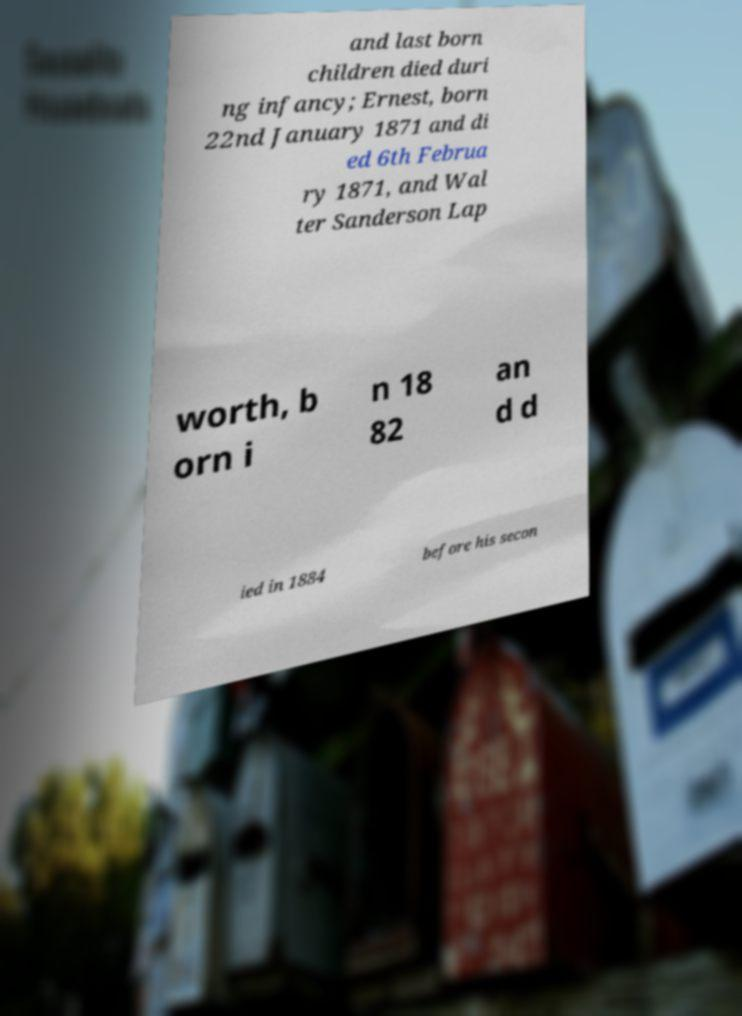I need the written content from this picture converted into text. Can you do that? and last born children died duri ng infancy; Ernest, born 22nd January 1871 and di ed 6th Februa ry 1871, and Wal ter Sanderson Lap worth, b orn i n 18 82 an d d ied in 1884 before his secon 